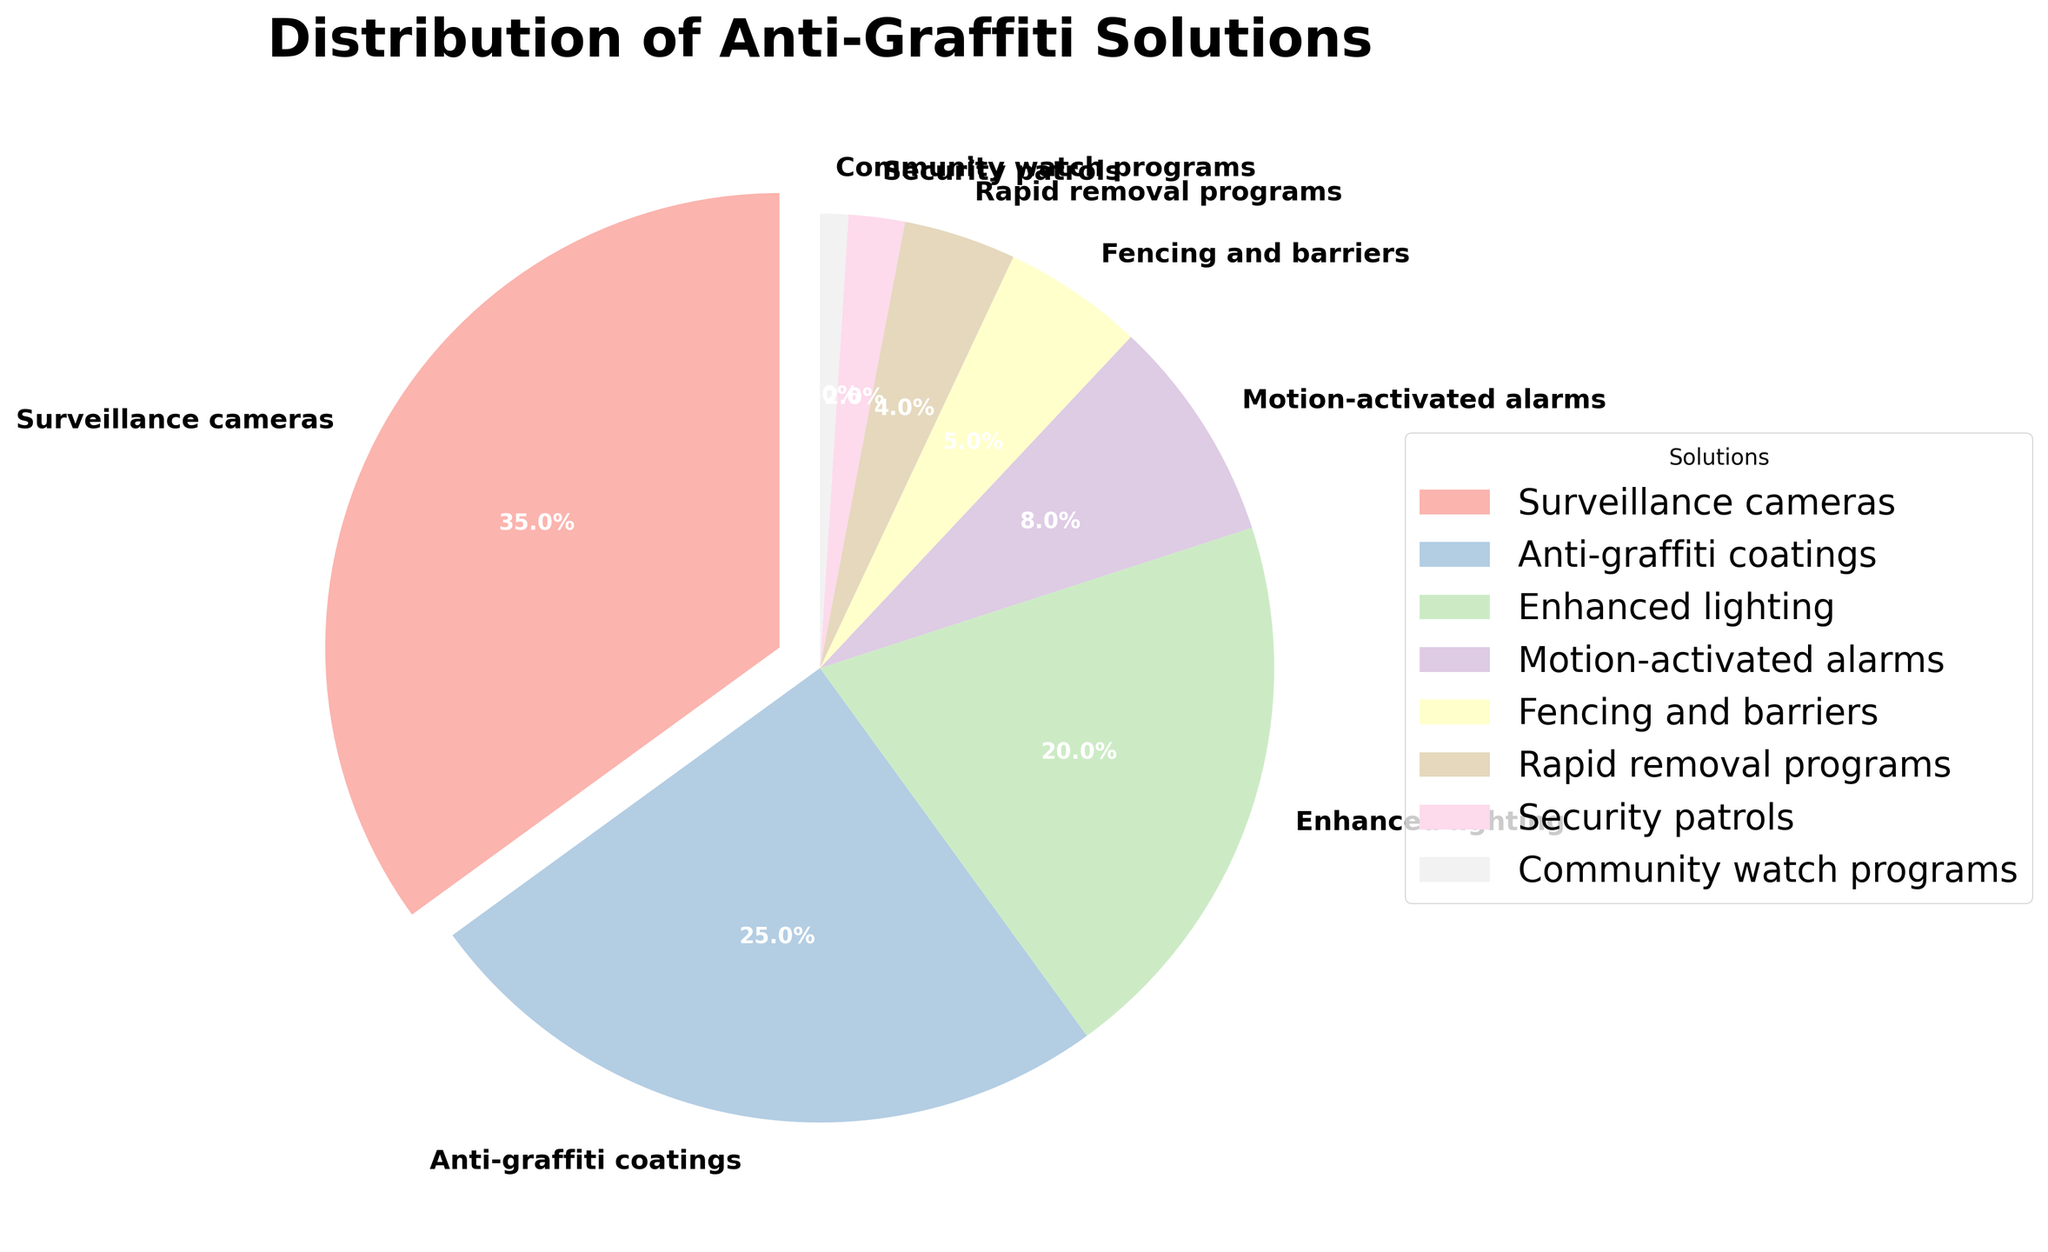What is the most commonly implemented anti-graffiti solution? The figure shows that "Surveillance cameras" take up the largest portion of the pie chart. The portion is 35%. Therefore, the most commonly implemented solution is surveillance cameras.
Answer: Surveillance cameras Which solution is implemented more between enhanced lighting and anti-graffiti coatings? By comparing the two slices of the pie chart, "Anti-graffiti coatings" have a 25% share while "Enhanced lighting" has a 20% share, making anti-graffiti coatings more commonly implemented.
Answer: Anti-graffiti coatings What percentage of businesses implement solutions other than surveillance cameras and anti-graffiti coatings? First, add the percentage of surveillance cameras and anti-graffiti coatings: 35% + 25% = 60%. Then subtract that from 100%: 100% - 60% = 40%. Therefore, 40% of businesses implement other solutions.
Answer: 40% Do more businesses implement fencing and barriers or rapid removal programs? Comparing the portion sizes of "Fencing and barriers" (5%) and "Rapid removal programs" (4%), we see that fencing and barriers are implemented more frequently.
Answer: Fencing and barriers Which solution is the least commonly implemented? The smallest slice in the pie chart is attributed to "Community watch programs" at 1%. This makes it the least commonly implemented solution.
Answer: Community watch programs What is the combined percentage of businesses that implement fencing and barriers, rapid removal programs, and security patrols? Adding the percentages of "Fencing and barriers" (5%), "Rapid removal programs" (4%), and "Security patrols" (2%) gives us 5% + 4% + 2% = 11%. Therefore, the combined percentage is 11%.
Answer: 11% How much more prevalent are surveillance cameras compared to community watch programs? The percentage for "Surveillance cameras" is 35%, and the percentage for "Community watch programs" is 1%. Subtract 1% from 35% to find the difference: 35% - 1% = 34%.
Answer: 34% What is the difference in percentage points between the use of enhanced lighting and motion-activated alarms? The percentage for "Enhanced lighting" is 20%, and the percentage for "Motion-activated alarms" is 8%. Subtract 8% from 20% to find the difference: 20% - 8% = 12%.
Answer: 12% Which solution appears in a shade of pink on the chart? By observing the color distribution in the pie chart and identifying the shade of pink, we see that "Anti-graffiti coatings" is represented in this shade.
Answer: Anti-graffiti coatings 